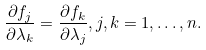Convert formula to latex. <formula><loc_0><loc_0><loc_500><loc_500>\frac { \partial f _ { j } } { \partial \lambda _ { k } } = \frac { \partial f _ { k } } { \partial \lambda _ { j } } , j , k = 1 , \dots , n .</formula> 